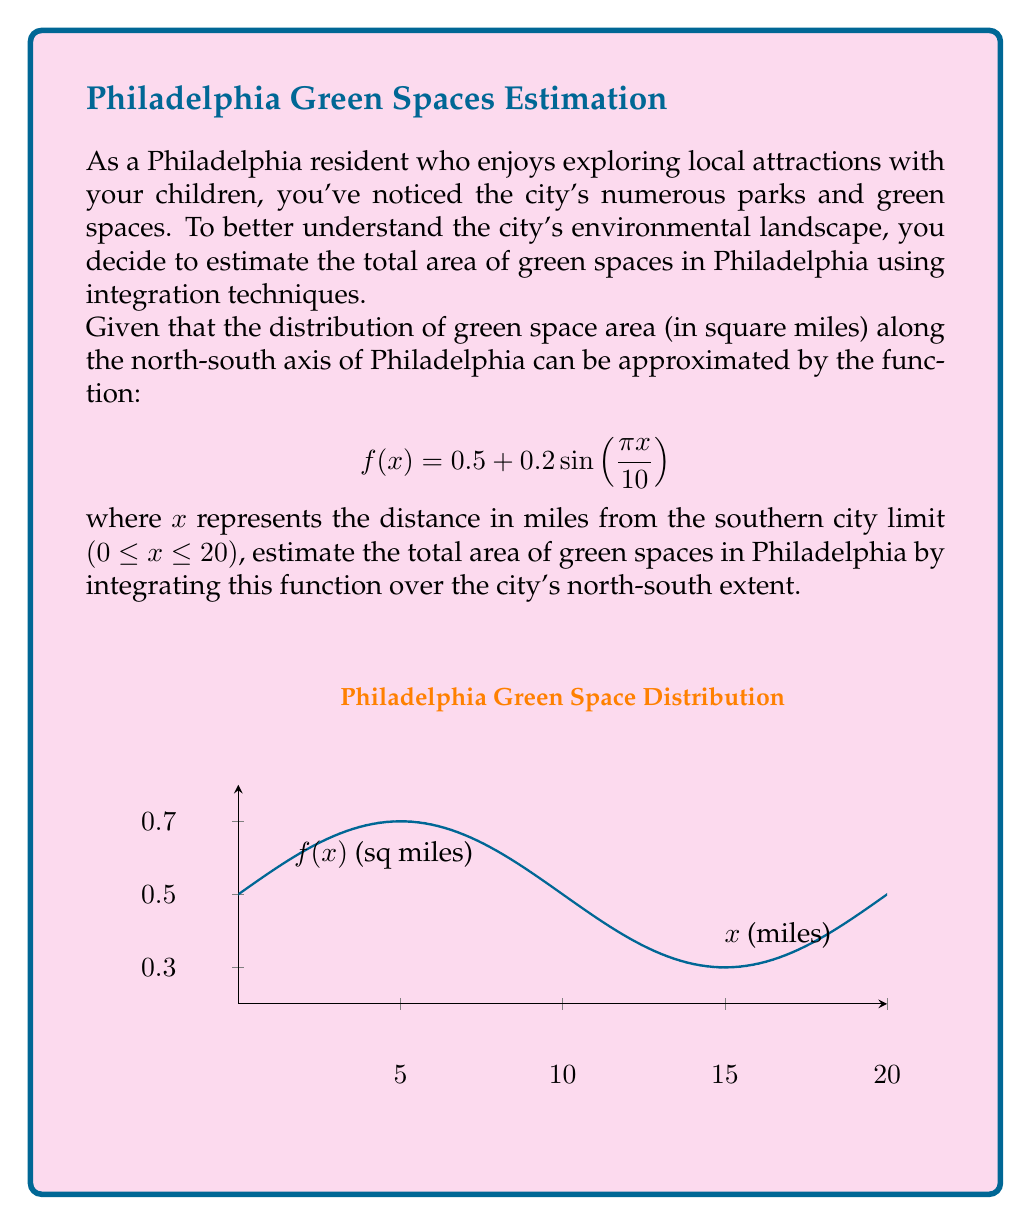What is the answer to this math problem? To estimate the total area of green spaces in Philadelphia, we need to integrate the given function over the interval [0, 20], which represents the north-south extent of the city.

The function to integrate is:
$$f(x) = 0.5 + 0.2\sin(\frac{\pi x}{10})$$

Step 1: Set up the definite integral
$$\int_0^{20} (0.5 + 0.2\sin(\frac{\pi x}{10})) dx$$

Step 2: Integrate the constant term
$$0.5x \bigg|_0^{20} + \int_0^{20} 0.2\sin(\frac{\pi x}{10}) dx$$

Step 3: Use the substitution method for the sine integral
Let $u = \frac{\pi x}{10}$, then $du = \frac{\pi}{10} dx$ and $dx = \frac{10}{\pi} du$

The new limits are:
When $x = 0$, $u = 0$
When $x = 20$, $u = 2\pi$

$$0.5x \bigg|_0^{20} + \frac{2}{\pi} \int_0^{2\pi} \sin(u) du$$

Step 4: Evaluate the integrals
$$0.5(20) - 0.5(0) + \frac{2}{\pi} [-\cos(u)] \bigg|_0^{2\pi}$$
$$= 10 + \frac{2}{\pi} [-\cos(2\pi) + \cos(0)]$$
$$= 10 + \frac{2}{\pi} [-(1) + 1]$$
$$= 10 + \frac{2}{\pi} (0)$$
$$= 10$$

Therefore, the estimated total area of green spaces in Philadelphia is 10 square miles.
Answer: 10 square miles 